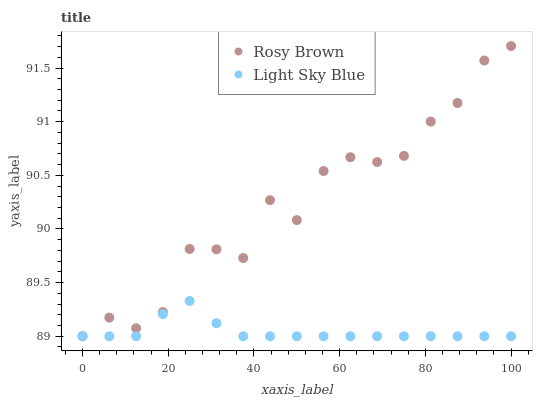Does Light Sky Blue have the minimum area under the curve?
Answer yes or no. Yes. Does Rosy Brown have the maximum area under the curve?
Answer yes or no. Yes. Does Light Sky Blue have the maximum area under the curve?
Answer yes or no. No. Is Light Sky Blue the smoothest?
Answer yes or no. Yes. Is Rosy Brown the roughest?
Answer yes or no. Yes. Is Light Sky Blue the roughest?
Answer yes or no. No. Does Rosy Brown have the lowest value?
Answer yes or no. Yes. Does Rosy Brown have the highest value?
Answer yes or no. Yes. Does Light Sky Blue have the highest value?
Answer yes or no. No. Does Rosy Brown intersect Light Sky Blue?
Answer yes or no. Yes. Is Rosy Brown less than Light Sky Blue?
Answer yes or no. No. Is Rosy Brown greater than Light Sky Blue?
Answer yes or no. No. 